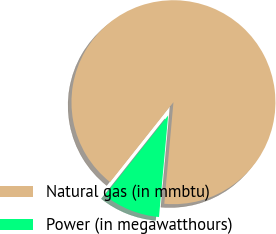<chart> <loc_0><loc_0><loc_500><loc_500><pie_chart><fcel>Natural gas (in mmbtu)<fcel>Power (in megawatthours)<nl><fcel>90.76%<fcel>9.24%<nl></chart> 